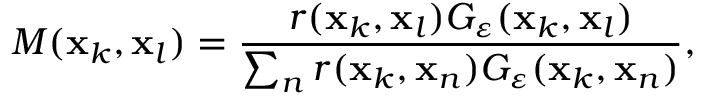<formula> <loc_0><loc_0><loc_500><loc_500>M ( x _ { k } , x _ { l } ) = \frac { r ( x _ { k } , x _ { l } ) G _ { \varepsilon } ( x _ { k } , x _ { l } ) } { \sum _ { n } r ( x _ { k } , x _ { n } ) G _ { \varepsilon } ( x _ { k } , x _ { n } ) } ,</formula> 